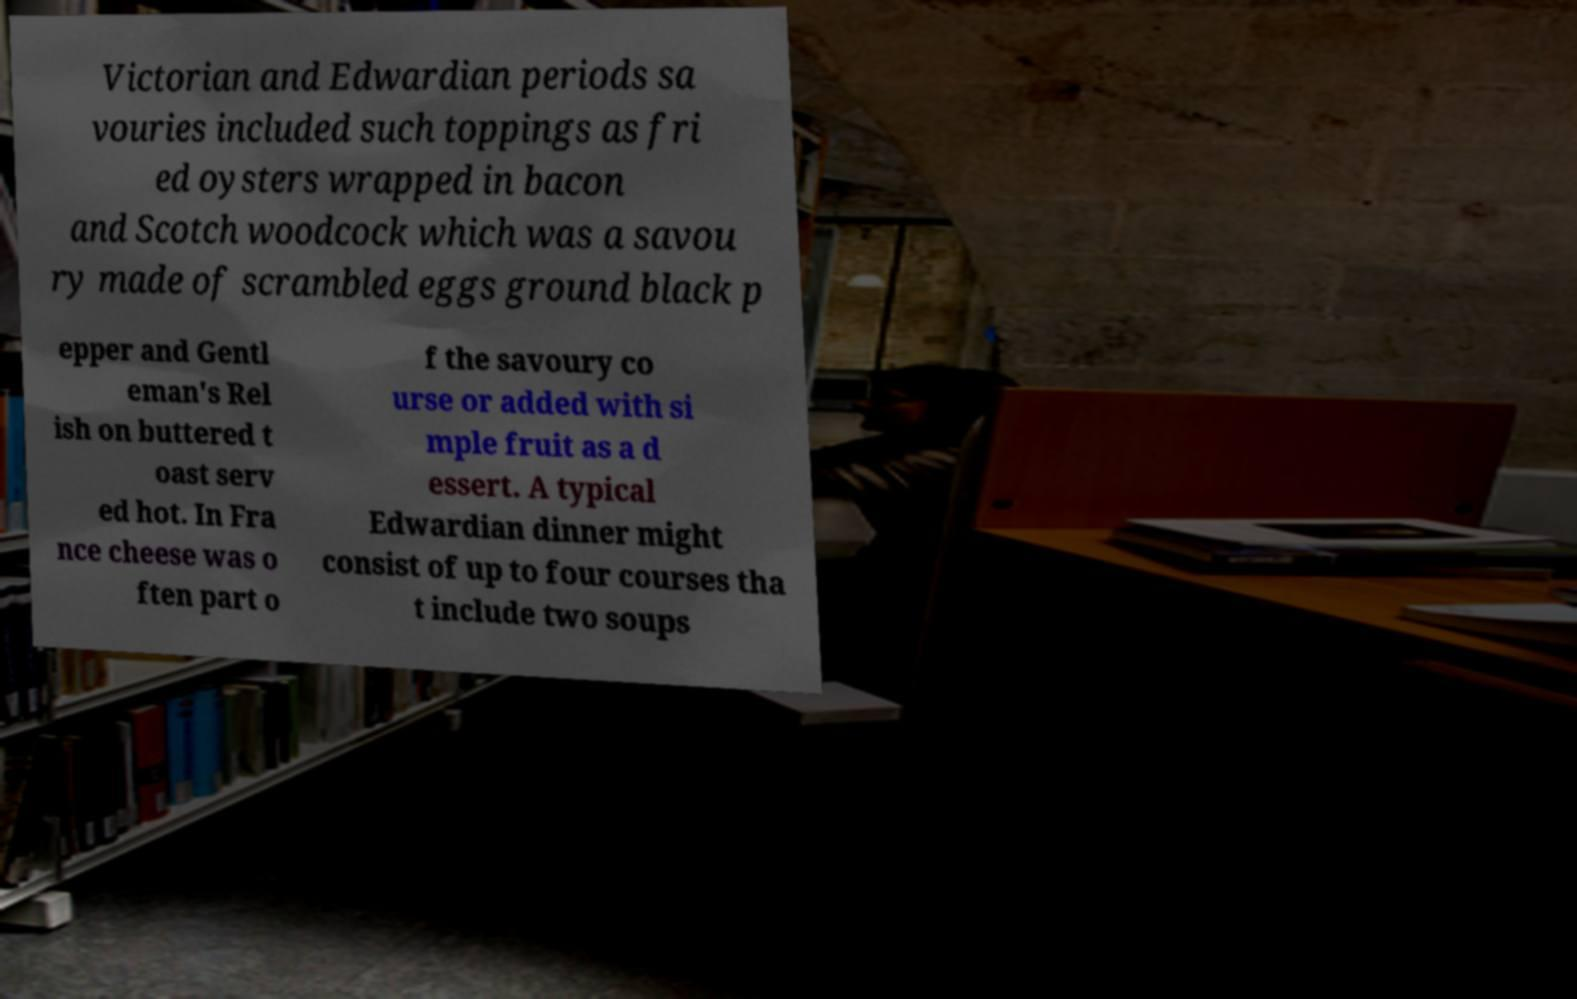Could you assist in decoding the text presented in this image and type it out clearly? Victorian and Edwardian periods sa vouries included such toppings as fri ed oysters wrapped in bacon and Scotch woodcock which was a savou ry made of scrambled eggs ground black p epper and Gentl eman's Rel ish on buttered t oast serv ed hot. In Fra nce cheese was o ften part o f the savoury co urse or added with si mple fruit as a d essert. A typical Edwardian dinner might consist of up to four courses tha t include two soups 